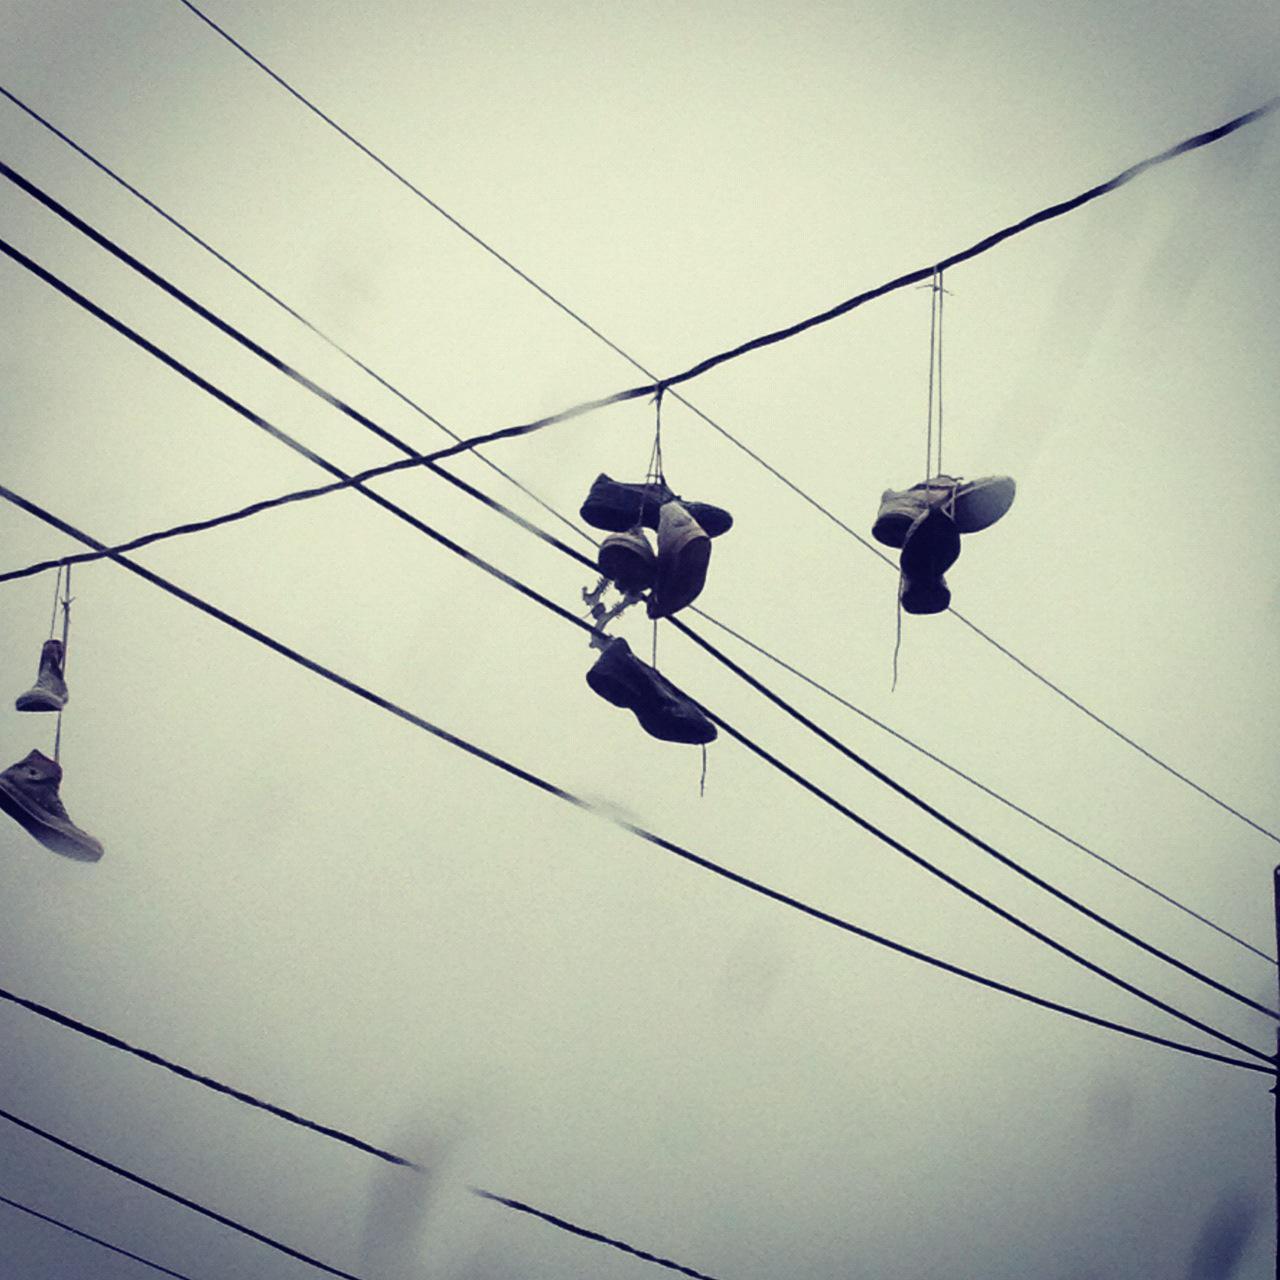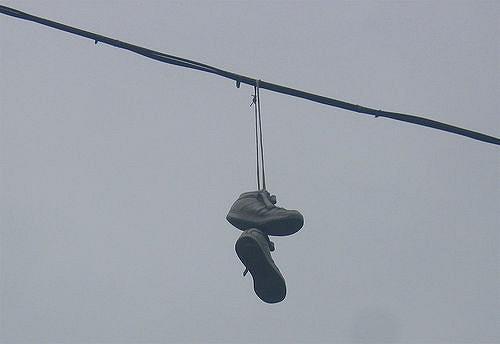The first image is the image on the left, the second image is the image on the right. Considering the images on both sides, is "There are exactly two shoes hanging on the line in the image on the right" valid? Answer yes or no. Yes. 